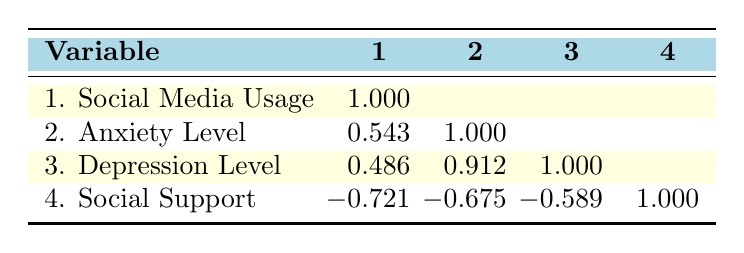What is the correlation between social media usage and anxiety level? The correlation value between social media usage and anxiety level is 0.543, indicating a moderate positive correlation, suggesting that as social media usage increases, anxiety levels also tend to increase.
Answer: 0.543 Is there a strong correlation between anxiety level and depression level? The correlation value between anxiety level and depression level is 0.912, indicating a strong positive correlation, meaning that an increase in anxiety levels is associated with an increase in depression levels.
Answer: Yes What is the average social support score among the adolescents? The social support scores listed are 4, 3, 5, 2, 3, 6, 2, 5, 4, 3. Adding these together gives 4 + 3 + 5 + 2 + 3 + 6 + 2 + 5 + 4 + 3 = 43. There are 10 adolescents, so the average is 43/10 = 4.3.
Answer: 4.3 Is there a negative correlation between social support score and social media usage? The correlation value between social support score and social media usage is -0.721, indicating a strong negative correlation, which means that as social media usage increases, social support scores tend to decrease.
Answer: Yes What is the difference in correlation values between depression level and social support score compared to anxiety level and social support score? The correlation value between anxiety level and social support score is -0.675 and the correlation value between depression level and social support score is -0.589. The difference between these two values is -0.589 - (-0.675) = 0.086, indicating a smaller negative correlation for depression compared to anxiety.
Answer: 0.086 How does the correlation between social media usage and depression level compare to the correlation between social media usage and anxiety level? The correlation between social media usage and depression level is 0.486, while the correlation with anxiety level is 0.543. The anxiety level has a stronger positive correlation with social media usage compared to depression level.
Answer: Anxiety level is stronger What is the least strong correlation presented in the table? The least strong correlation is between social media usage and depression level, which has a correlation value of 0.486, indicating a weaker relationship compared to other correlations in the table.
Answer: 0.486 